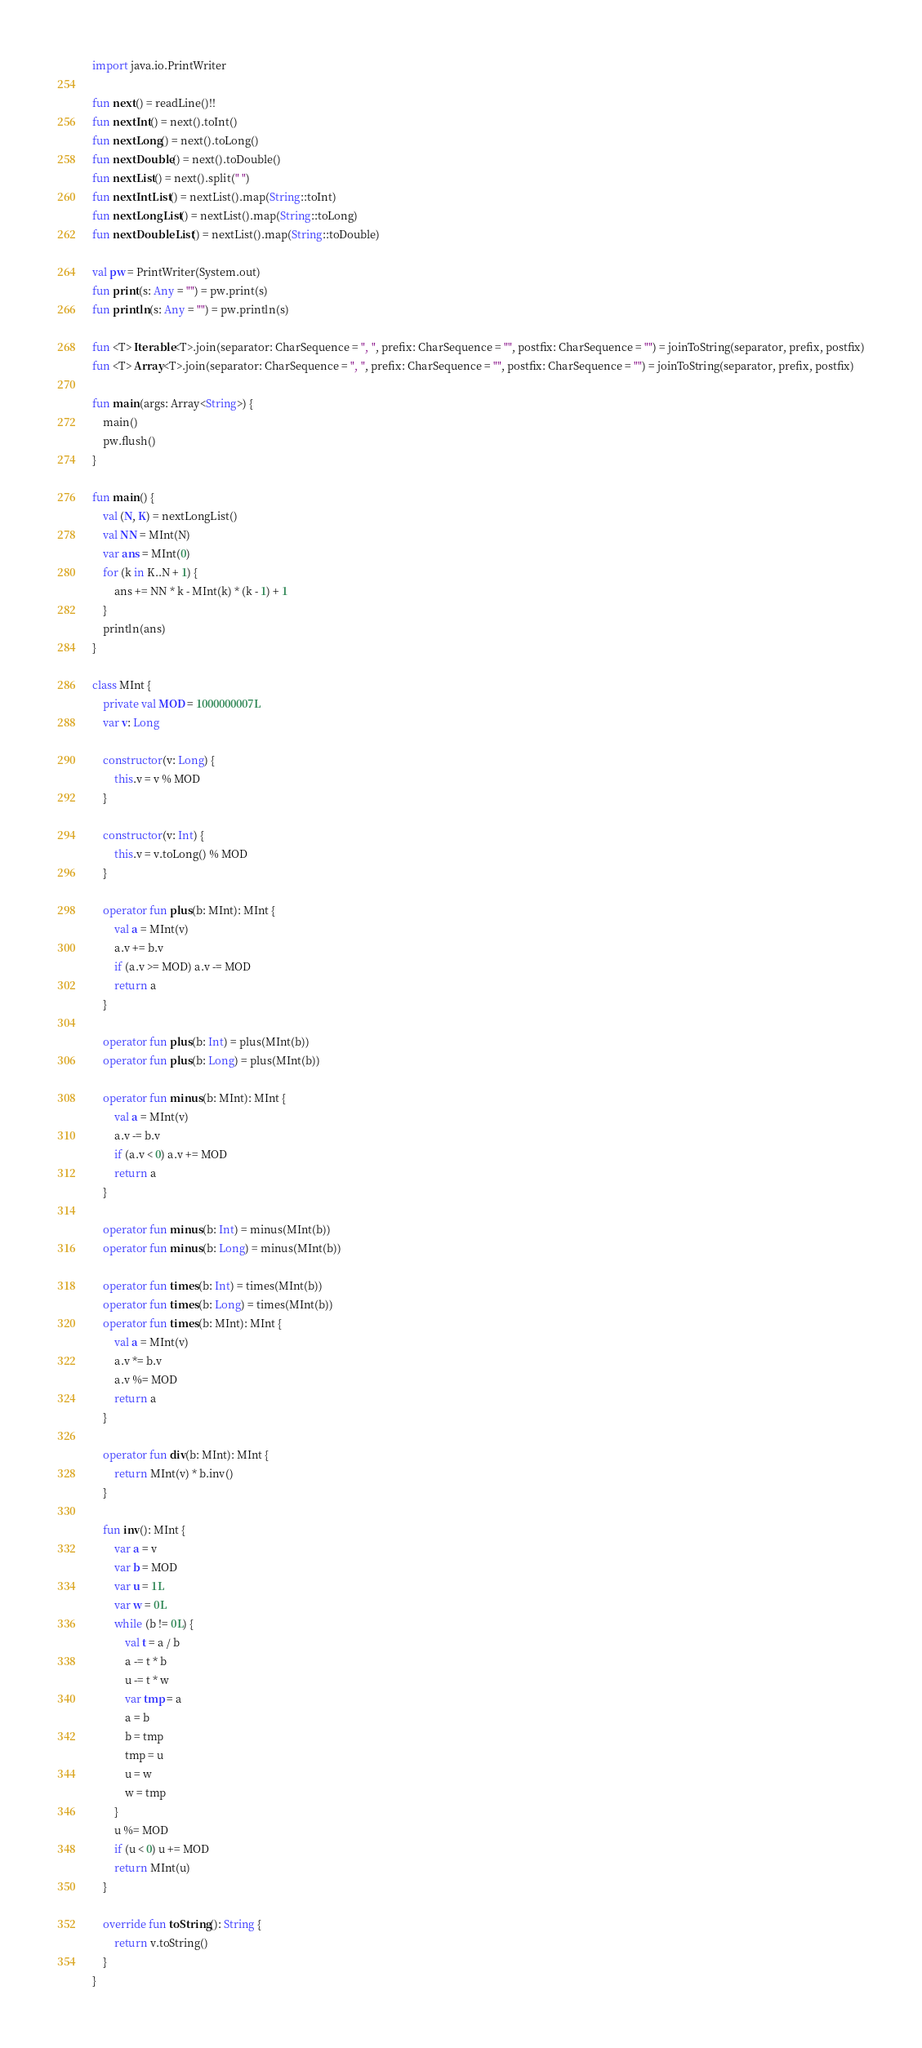<code> <loc_0><loc_0><loc_500><loc_500><_Kotlin_>import java.io.PrintWriter

fun next() = readLine()!!
fun nextInt() = next().toInt()
fun nextLong() = next().toLong()
fun nextDouble() = next().toDouble()
fun nextList() = next().split(" ")
fun nextIntList() = nextList().map(String::toInt)
fun nextLongList() = nextList().map(String::toLong)
fun nextDoubleList() = nextList().map(String::toDouble)

val pw = PrintWriter(System.out)
fun print(s: Any = "") = pw.print(s)
fun println(s: Any = "") = pw.println(s)

fun <T> Iterable<T>.join(separator: CharSequence = ", ", prefix: CharSequence = "", postfix: CharSequence = "") = joinToString(separator, prefix, postfix)
fun <T> Array<T>.join(separator: CharSequence = ", ", prefix: CharSequence = "", postfix: CharSequence = "") = joinToString(separator, prefix, postfix)

fun main(args: Array<String>) {
    main()
    pw.flush()
}

fun main() {
    val (N, K) = nextLongList()
    val NN = MInt(N)
    var ans = MInt(0)
    for (k in K..N + 1) {
        ans += NN * k - MInt(k) * (k - 1) + 1
    }
    println(ans)
}

class MInt {
    private val MOD = 1000000007L
    var v: Long

    constructor(v: Long) {
        this.v = v % MOD
    }

    constructor(v: Int) {
        this.v = v.toLong() % MOD
    }

    operator fun plus(b: MInt): MInt {
        val a = MInt(v)
        a.v += b.v
        if (a.v >= MOD) a.v -= MOD
        return a
    }

    operator fun plus(b: Int) = plus(MInt(b))
    operator fun plus(b: Long) = plus(MInt(b))

    operator fun minus(b: MInt): MInt {
        val a = MInt(v)
        a.v -= b.v
        if (a.v < 0) a.v += MOD
        return a
    }

    operator fun minus(b: Int) = minus(MInt(b))
    operator fun minus(b: Long) = minus(MInt(b))

    operator fun times(b: Int) = times(MInt(b))
    operator fun times(b: Long) = times(MInt(b))
    operator fun times(b: MInt): MInt {
        val a = MInt(v)
        a.v *= b.v
        a.v %= MOD
        return a
    }

    operator fun div(b: MInt): MInt {
        return MInt(v) * b.inv()
    }

    fun inv(): MInt {
        var a = v
        var b = MOD
        var u = 1L
        var w = 0L
        while (b != 0L) {
            val t = a / b
            a -= t * b
            u -= t * w
            var tmp = a
            a = b
            b = tmp
            tmp = u
            u = w
            w = tmp
        }
        u %= MOD
        if (u < 0) u += MOD
        return MInt(u)
    }

    override fun toString(): String {
        return v.toString()
    }
}</code> 